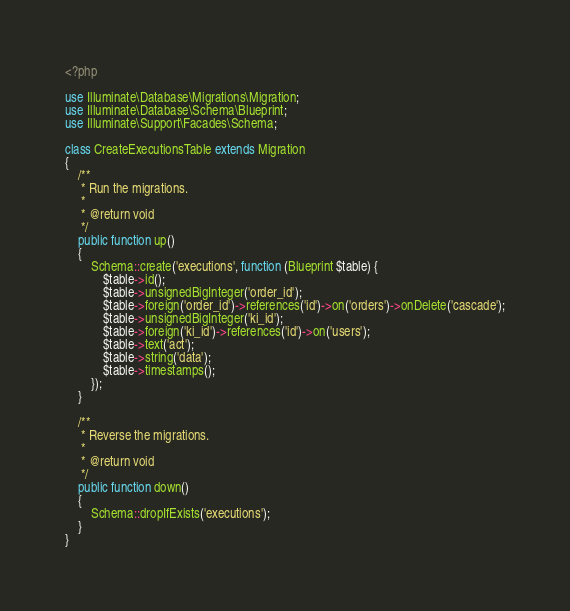Convert code to text. <code><loc_0><loc_0><loc_500><loc_500><_PHP_><?php

use Illuminate\Database\Migrations\Migration;
use Illuminate\Database\Schema\Blueprint;
use Illuminate\Support\Facades\Schema;

class CreateExecutionsTable extends Migration
{
    /**
     * Run the migrations.
     *
     * @return void
     */
    public function up()
    {
        Schema::create('executions', function (Blueprint $table) {
            $table->id();
            $table->unsignedBigInteger('order_id');
            $table->foreign('order_id')->references('id')->on('orders')->onDelete('cascade');
            $table->unsignedBigInteger('ki_id');
            $table->foreign('ki_id')->references('id')->on('users');
            $table->text('act');
            $table->string('data');
            $table->timestamps();
        });
    }

    /**
     * Reverse the migrations.
     *
     * @return void
     */
    public function down()
    {
        Schema::dropIfExists('executions');
    }
}
</code> 